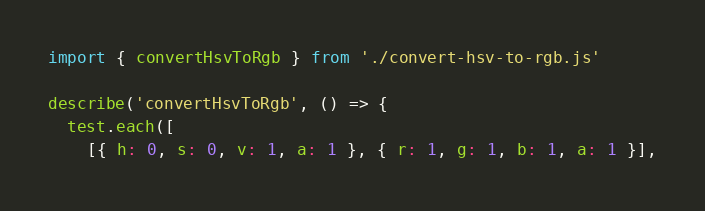Convert code to text. <code><loc_0><loc_0><loc_500><loc_500><_JavaScript_>import { convertHsvToRgb } from './convert-hsv-to-rgb.js'

describe('convertHsvToRgb', () => {
  test.each([
    [{ h: 0, s: 0, v: 1, a: 1 }, { r: 1, g: 1, b: 1, a: 1 }],</code> 